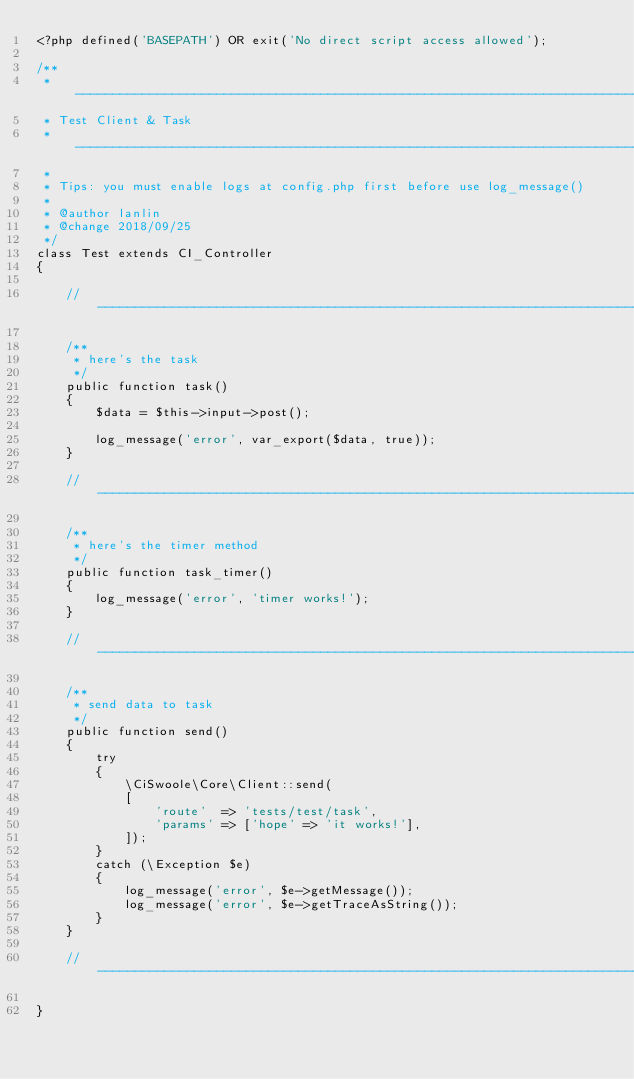Convert code to text. <code><loc_0><loc_0><loc_500><loc_500><_PHP_><?php defined('BASEPATH') OR exit('No direct script access allowed');

/**
 * ----------------------------------------------------------------------------------
 * Test Client & Task
 * ----------------------------------------------------------------------------------
 *
 * Tips: you must enable logs at config.php first before use log_message()
 *
 * @author lanlin
 * @change 2018/09/25
 */
class Test extends CI_Controller
{

    // ------------------------------------------------------------------------------

    /**
     * here's the task
     */
	public function task()
	{
	    $data = $this->input->post();

        log_message('error', var_export($data, true));
	}

    // ------------------------------------------------------------------------------

    /**
     * here's the timer method
     */
    public function task_timer()
    {
        log_message('error', 'timer works!');
    }

    // ------------------------------------------------------------------------------

    /**
     * send data to task
     */
	public function send()
    {
        try
        {
            \CiSwoole\Core\Client::send(
            [
                'route'  => 'tests/test/task',
                'params' => ['hope' => 'it works!'],
            ]);
        }
        catch (\Exception $e)
        {
            log_message('error', $e->getMessage());
            log_message('error', $e->getTraceAsString());
        }
    }

    // ------------------------------------------------------------------------------

}
</code> 